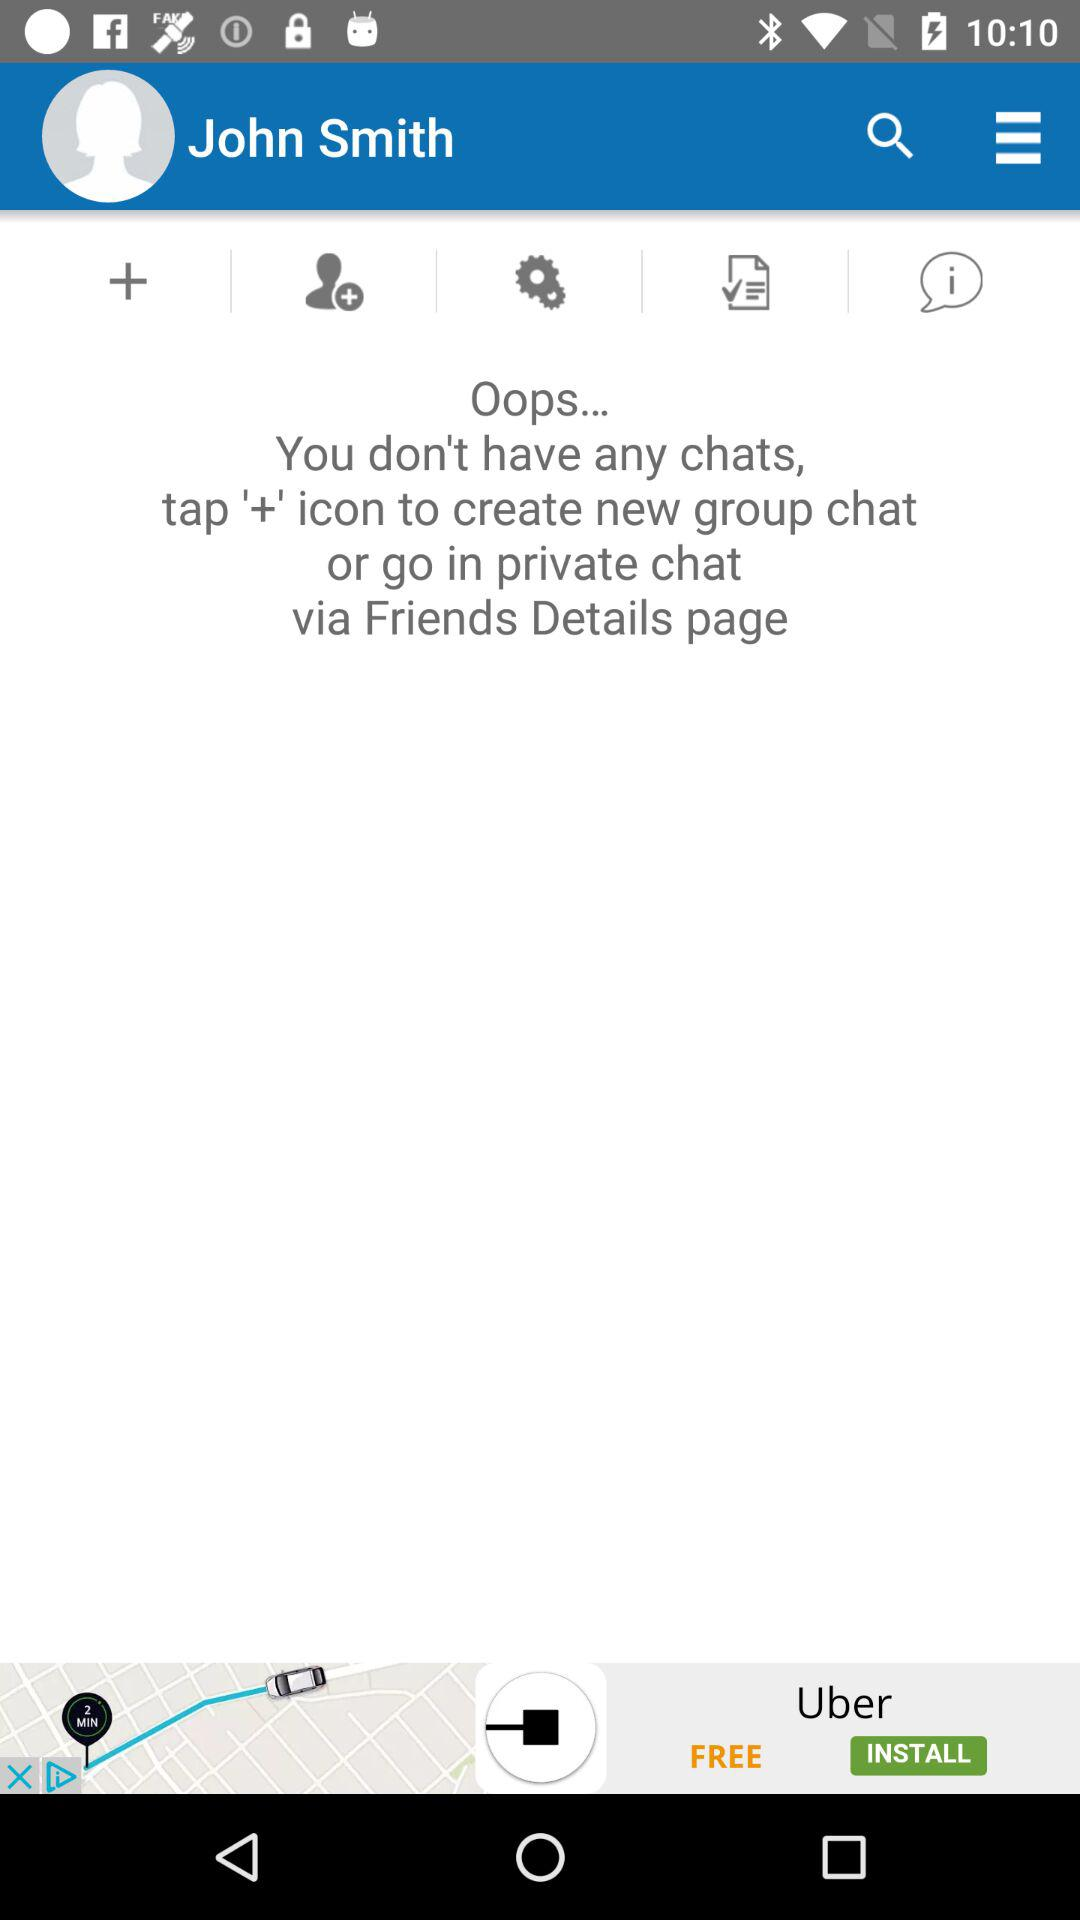What is the name of the user? The name of the user is John Smith. 